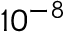<formula> <loc_0><loc_0><loc_500><loc_500>1 0 ^ { - 8 }</formula> 